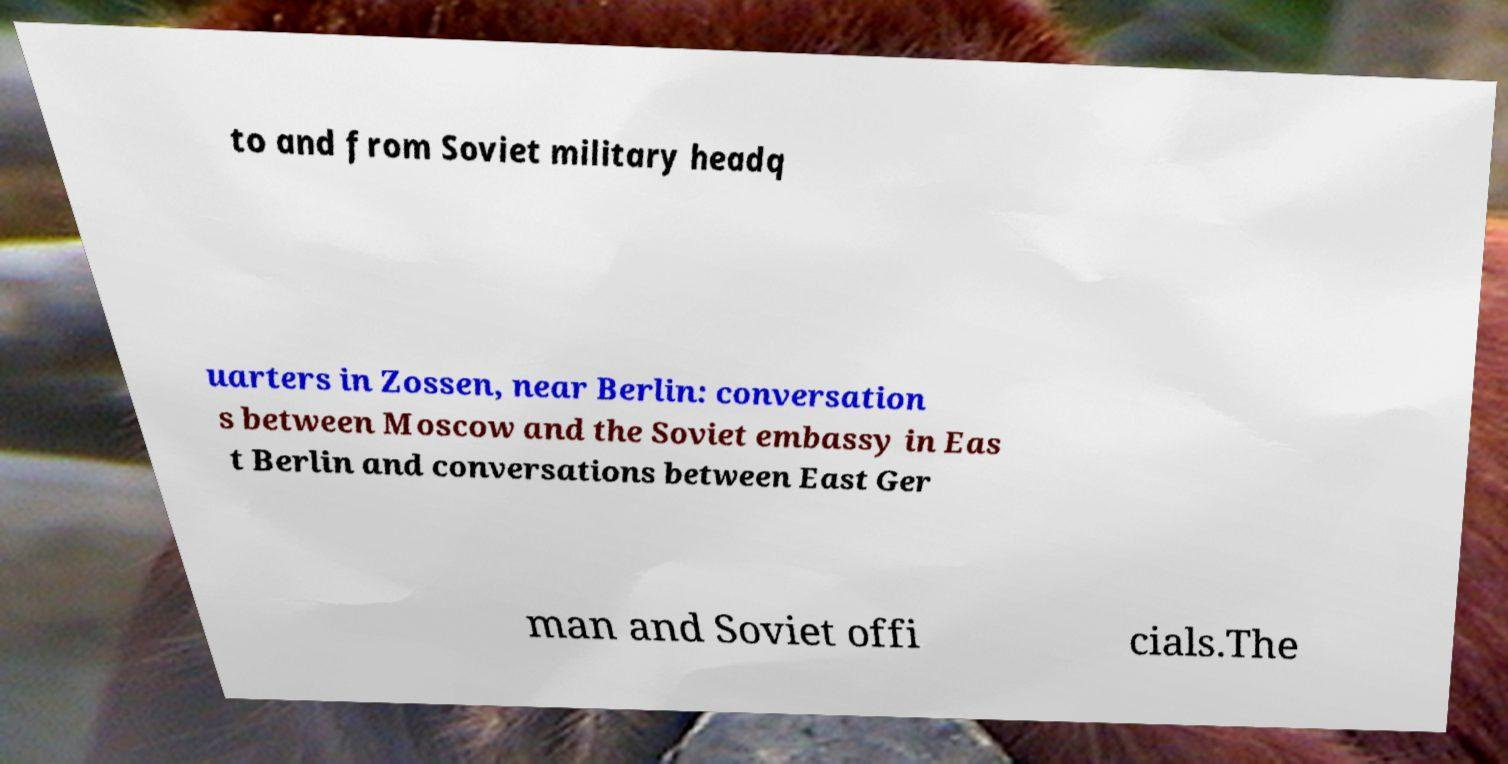Could you assist in decoding the text presented in this image and type it out clearly? to and from Soviet military headq uarters in Zossen, near Berlin: conversation s between Moscow and the Soviet embassy in Eas t Berlin and conversations between East Ger man and Soviet offi cials.The 